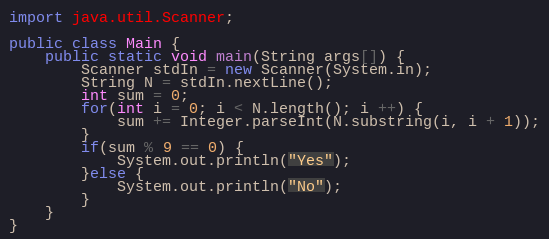Convert code to text. <code><loc_0><loc_0><loc_500><loc_500><_Java_>import java.util.Scanner;

public class Main {
	public static void main(String args[]) {
		Scanner stdIn = new Scanner(System.in);
		String N = stdIn.nextLine();
		int sum = 0;
		for(int i = 0; i < N.length(); i ++) {
			sum += Integer.parseInt(N.substring(i, i + 1));
		}
		if(sum % 9 == 0) {
			System.out.println("Yes");
		}else {
			System.out.println("No");
		}
	}
}</code> 